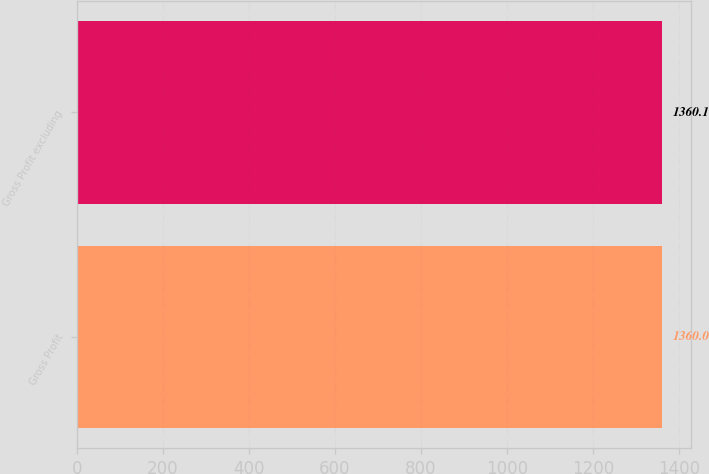Convert chart. <chart><loc_0><loc_0><loc_500><loc_500><bar_chart><fcel>Gross Profit<fcel>Gross Profit excluding<nl><fcel>1360<fcel>1360.1<nl></chart> 